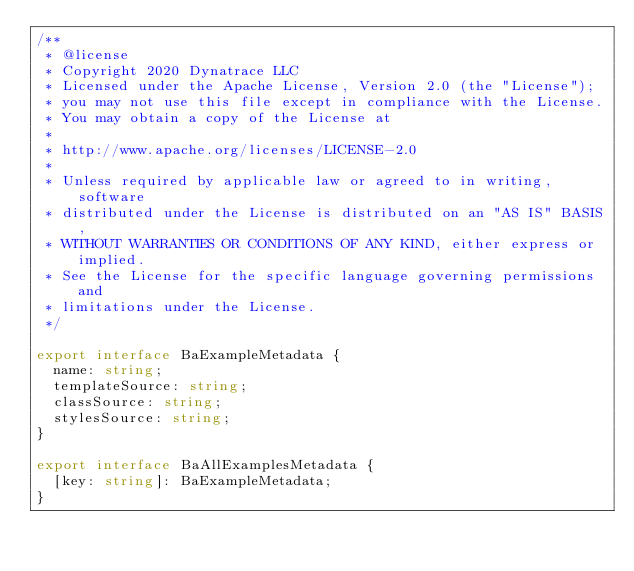<code> <loc_0><loc_0><loc_500><loc_500><_TypeScript_>/**
 * @license
 * Copyright 2020 Dynatrace LLC
 * Licensed under the Apache License, Version 2.0 (the "License");
 * you may not use this file except in compliance with the License.
 * You may obtain a copy of the License at
 *
 * http://www.apache.org/licenses/LICENSE-2.0
 *
 * Unless required by applicable law or agreed to in writing, software
 * distributed under the License is distributed on an "AS IS" BASIS,
 * WITHOUT WARRANTIES OR CONDITIONS OF ANY KIND, either express or implied.
 * See the License for the specific language governing permissions and
 * limitations under the License.
 */

export interface BaExampleMetadata {
  name: string;
  templateSource: string;
  classSource: string;
  stylesSource: string;
}

export interface BaAllExamplesMetadata {
  [key: string]: BaExampleMetadata;
}
</code> 